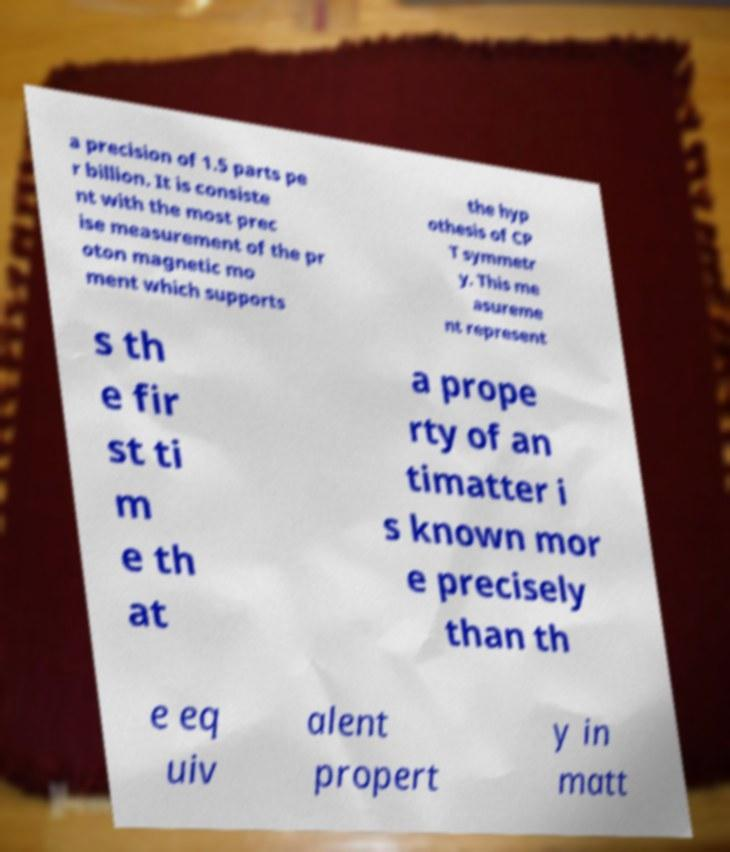Could you extract and type out the text from this image? a precision of 1.5 parts pe r billion. It is consiste nt with the most prec ise measurement of the pr oton magnetic mo ment which supports the hyp othesis of CP T symmetr y. This me asureme nt represent s th e fir st ti m e th at a prope rty of an timatter i s known mor e precisely than th e eq uiv alent propert y in matt 